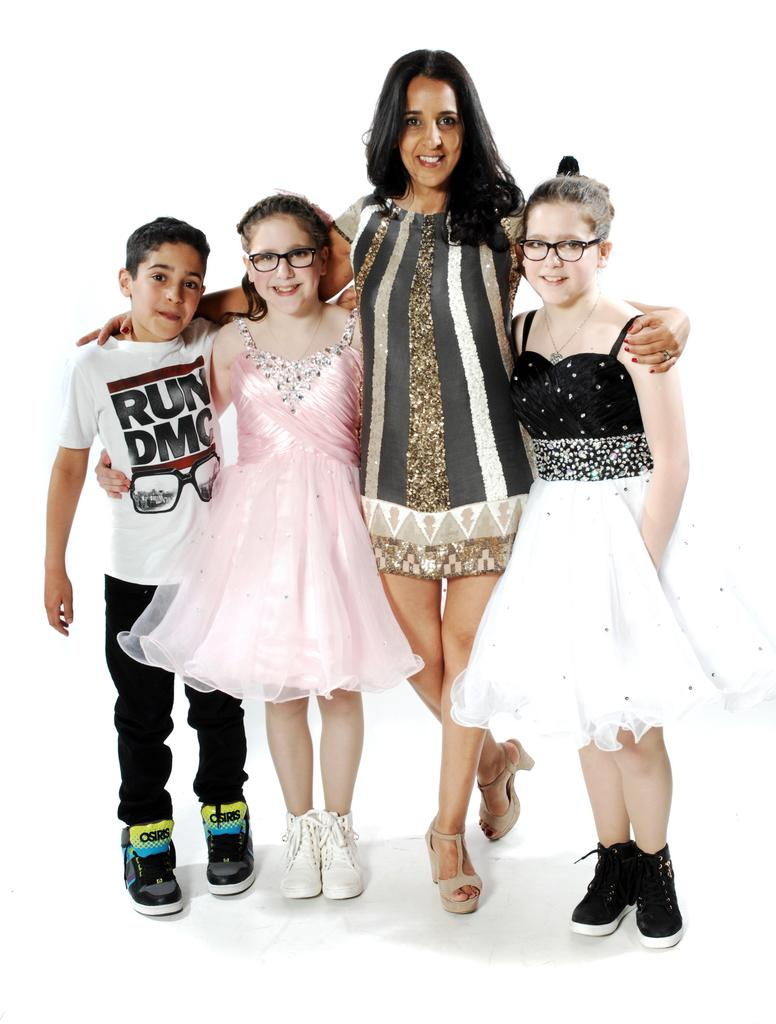What can be seen in the image? There are people standing in the image. Can you describe the appearance of some of the people? Some of the people are wearing glasses. What is the surface beneath the people in the image? There is a floor visible at the bottom of the image. What is the interest of the person laughing in the image? There is no person laughing in the image, and therefore no interest can be determined. 